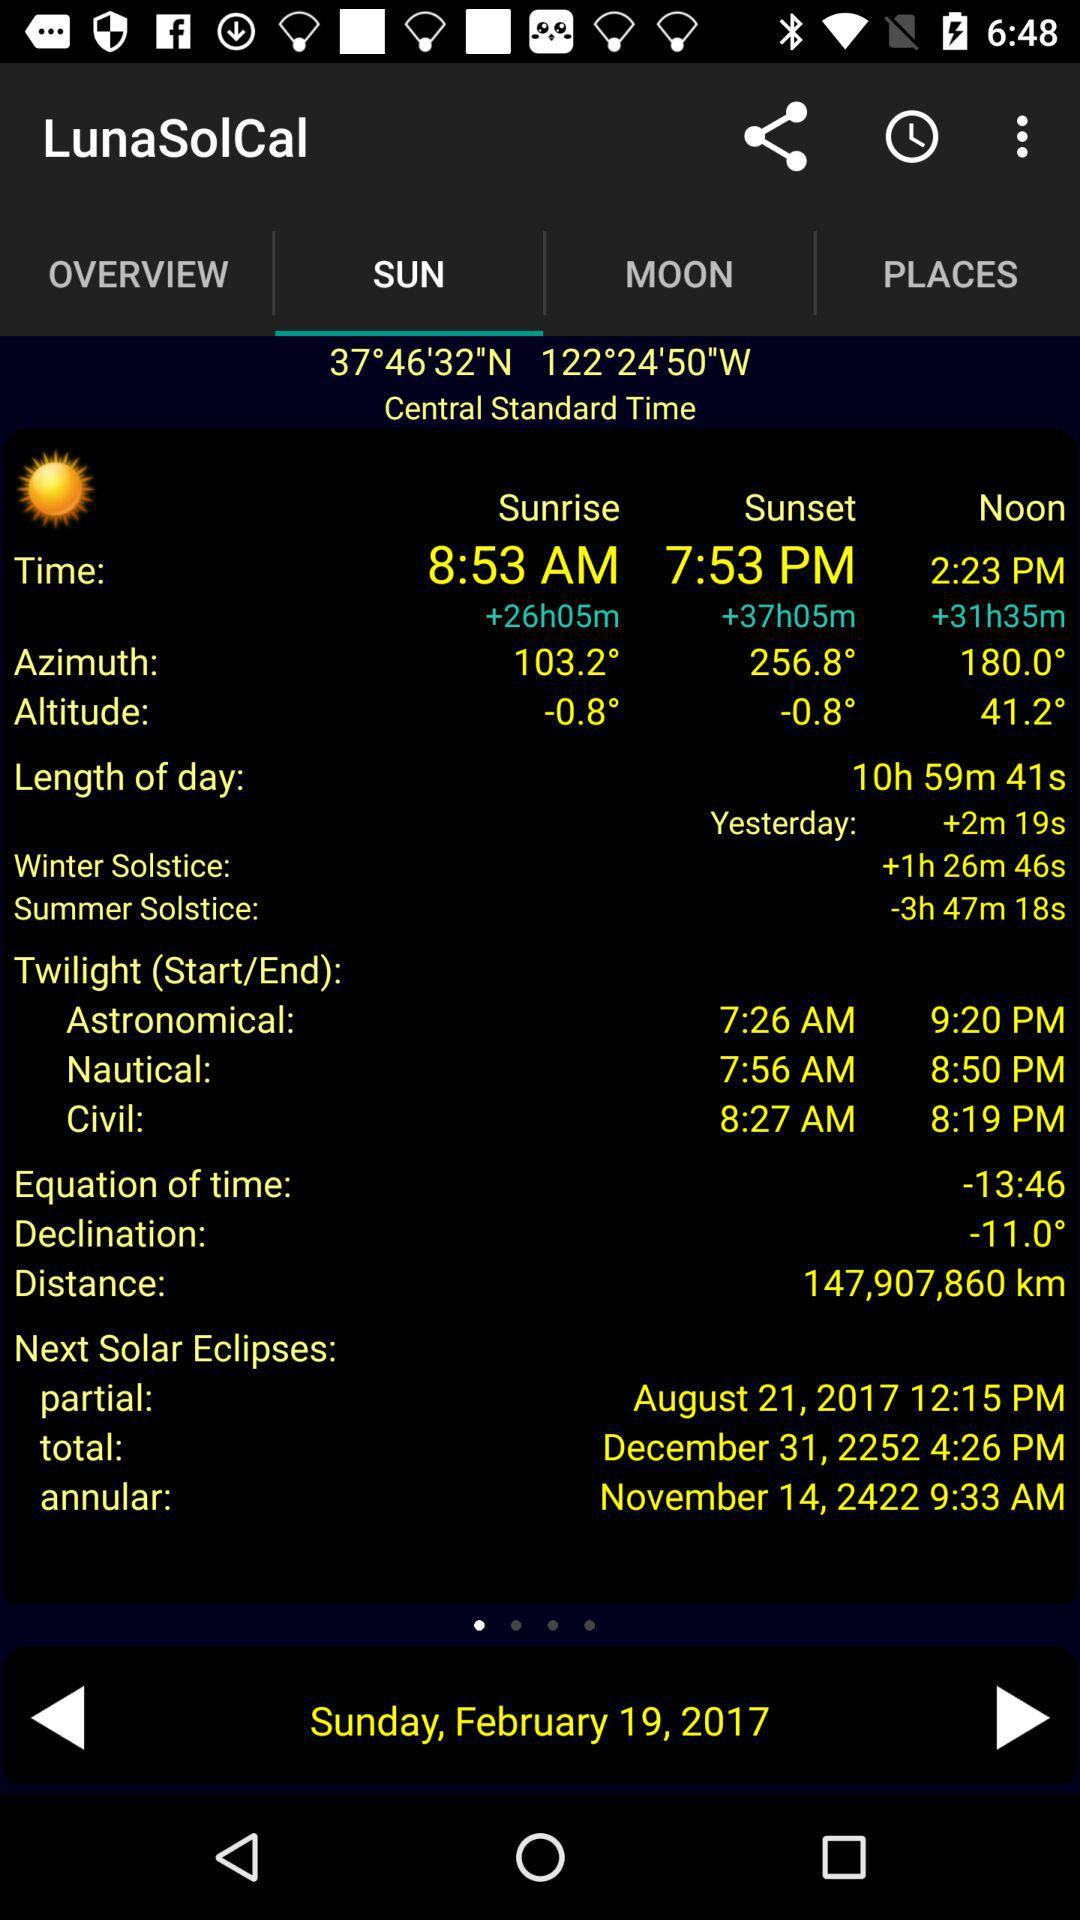What is the sunset time? The sunset time is 7:53 PM. 